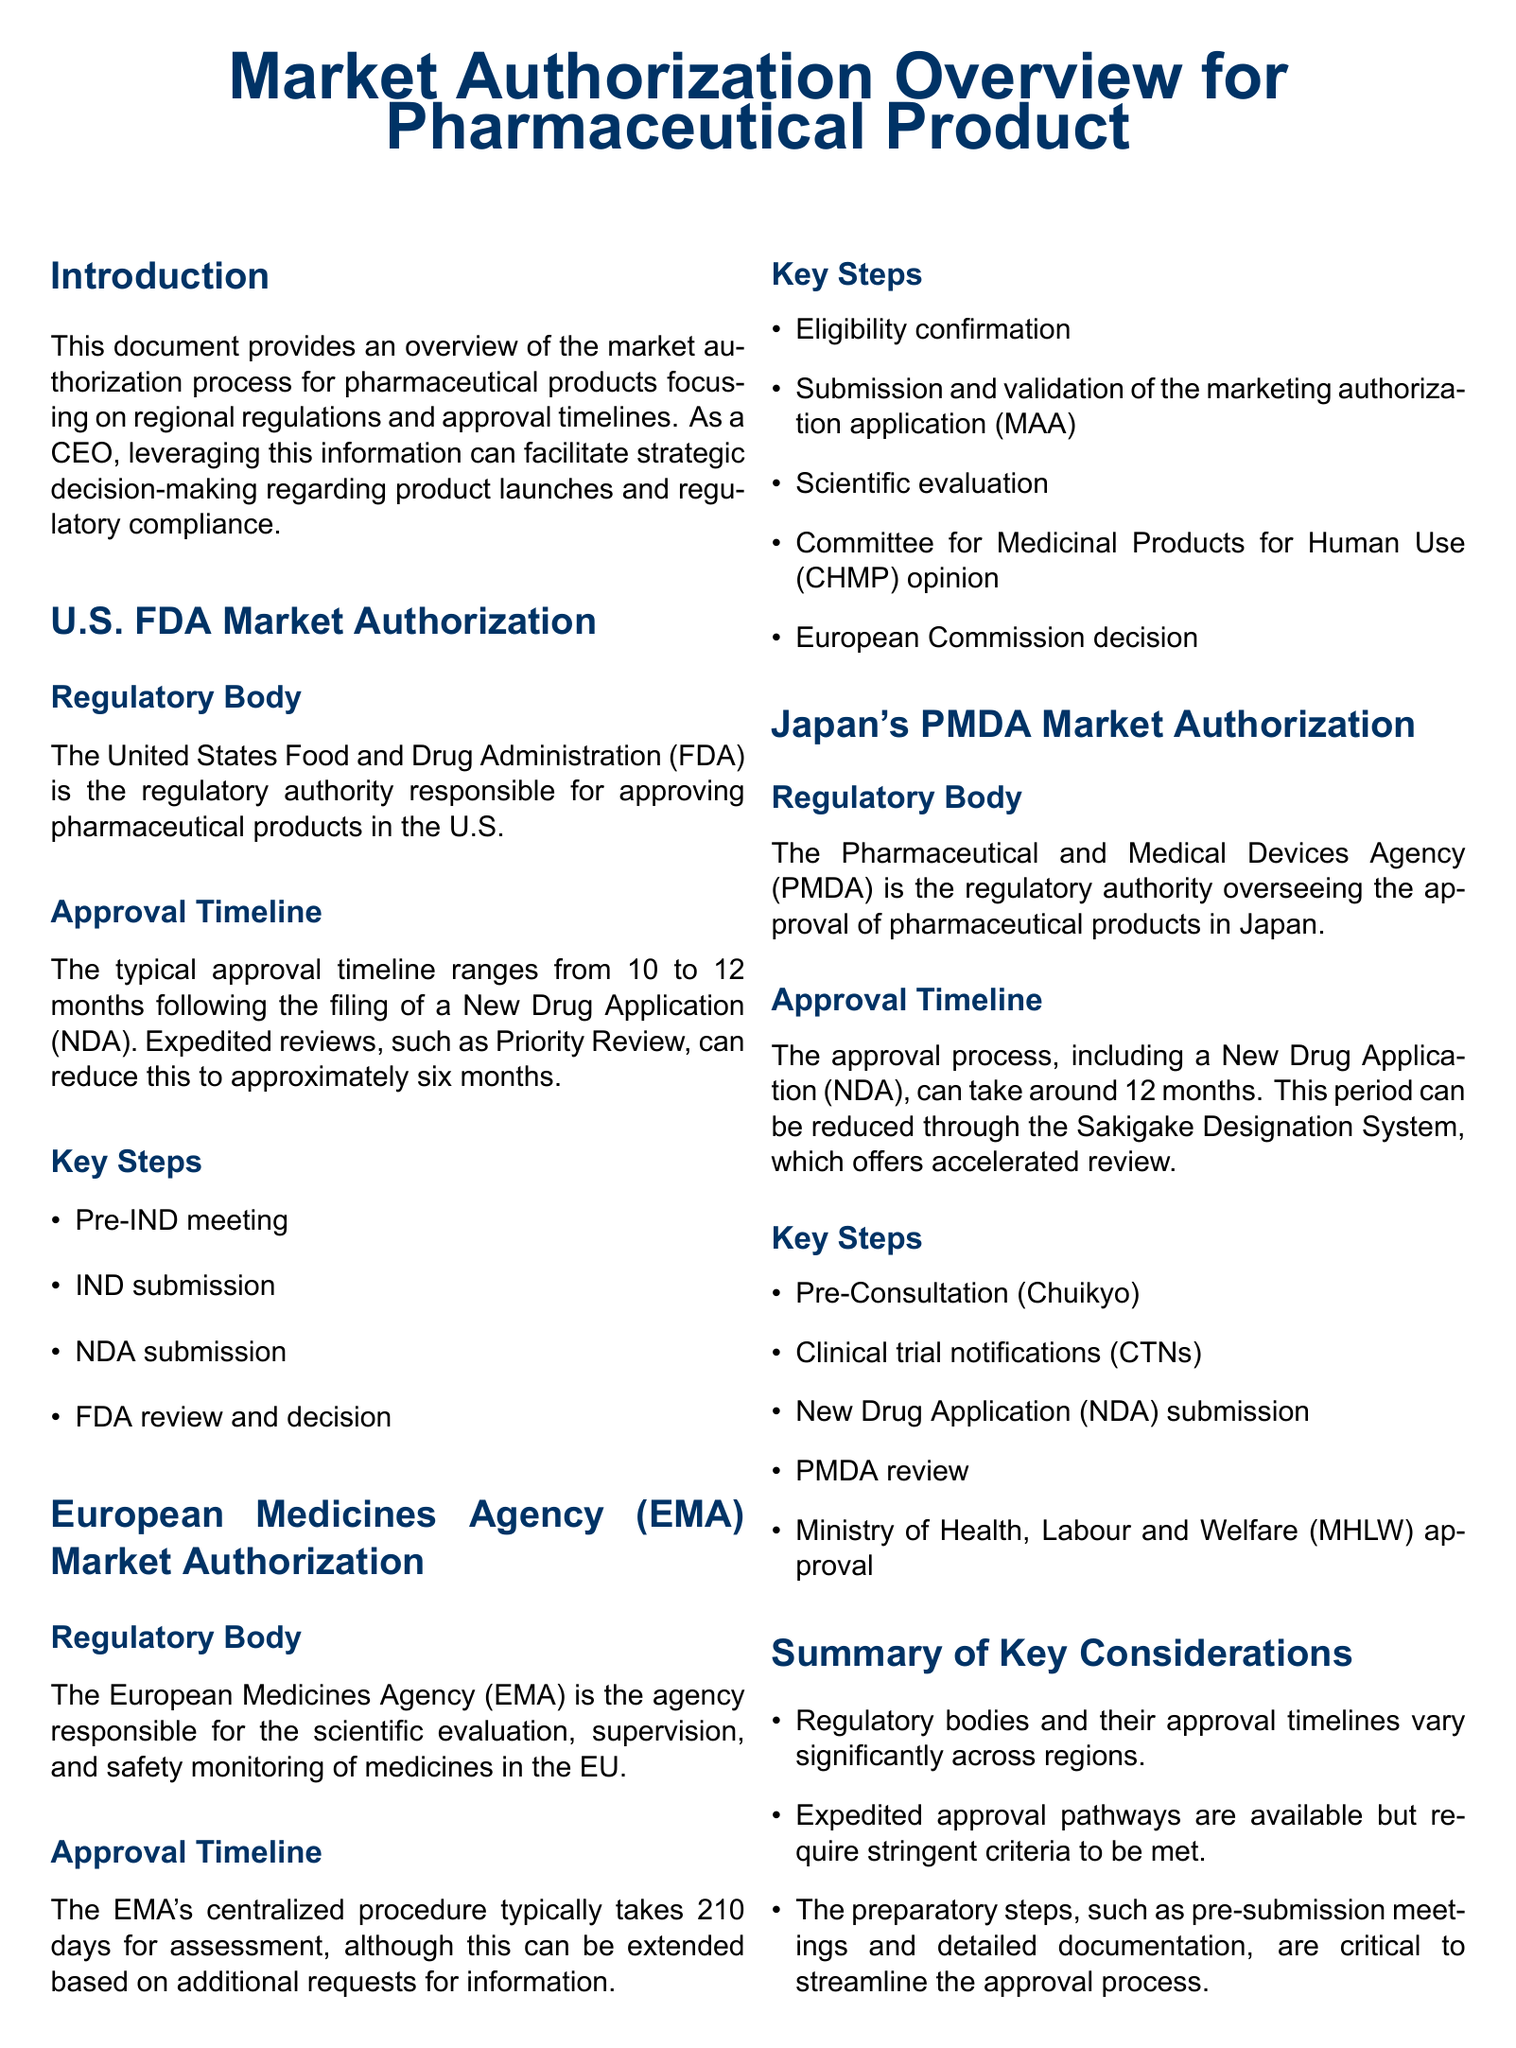What is the U.S. regulatory body for pharmaceuticals? The document states that the regulatory body in the U.S. is responsible for approving pharmaceutical products.
Answer: FDA What is the typical approval timeline for the EMA? The document indicates that the typical timeline for the EMA's centralized procedure is mentioned.
Answer: 210 days What is the expedited review timeline for the U.S. FDA? It specifies that expedited reviews, like Priority Review, can shorten the approval time.
Answer: 6 months Which agency oversees pharmaceutical approvals in Japan? The document names the agency responsible for the approval of pharmaceutical products in Japan.
Answer: PMDA What is one key step in the U.S. FDA approval process? The document lists critical steps involved in the regulatory process under the U.S. FDA.
Answer: NDA submission What designation system can reduce the approval timeline in Japan? The document mentions a system that allows for an accelerated review process in Japan.
Answer: Sakigake Designation System Which European body monitors the safety of medicines? The information refers to the agency responsible for the scientific evaluation of medicines in the EU.
Answer: EMA What should be consulted for detailed regulatory advice? The document suggests a source for thorough guidance regarding regulatory compliance and planning.
Answer: regulatory affairs manager 